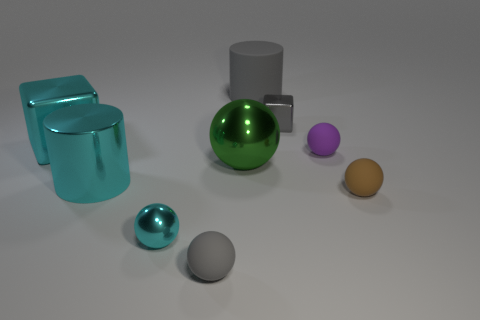The large ball has what color?
Provide a short and direct response. Green. What is the material of the big cylinder that is in front of the big cyan block?
Offer a very short reply. Metal. Is the shape of the large green metallic object the same as the small rubber thing in front of the tiny cyan object?
Keep it short and to the point. Yes. Are there more purple objects than big cylinders?
Offer a terse response. No. Are there any other things that are the same color as the large matte cylinder?
Your answer should be very brief. Yes. What is the shape of the tiny gray object that is the same material as the big cyan cylinder?
Keep it short and to the point. Cube. There is a brown thing to the right of the gray thing in front of the purple rubber sphere; what is it made of?
Keep it short and to the point. Rubber. There is a gray object that is in front of the cyan block; is it the same shape as the green metal thing?
Keep it short and to the point. Yes. Are there more tiny objects that are right of the big green object than red blocks?
Make the answer very short. Yes. The small object that is the same color as the large metallic cylinder is what shape?
Offer a terse response. Sphere. 